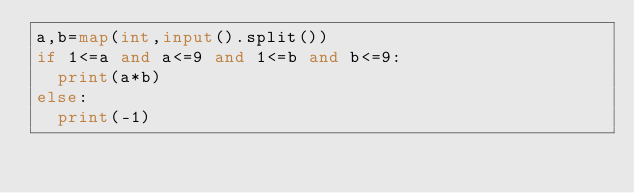Convert code to text. <code><loc_0><loc_0><loc_500><loc_500><_Python_>a,b=map(int,input().split())
if 1<=a and a<=9 and 1<=b and b<=9:
  print(a*b)
else:
  print(-1)</code> 